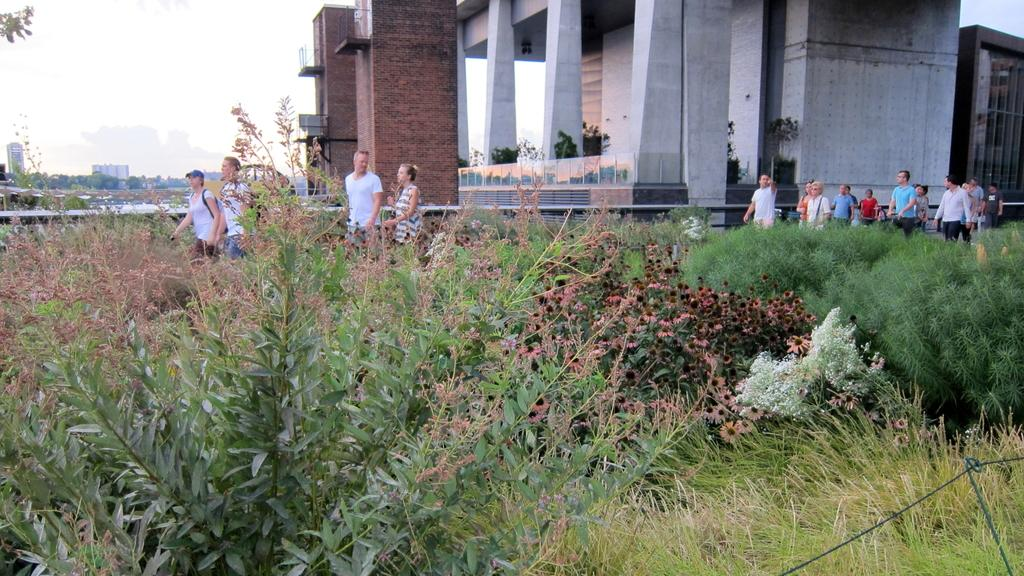What are the people in the image doing? The people in the image are walking. What can be seen under the people's feet in the image? The ground is visible in the image. What type of structure can be seen in the background of the image? There is a concrete house and a brick wall in the background of the image. What type of vegetation is present in the front bottom side of the image? Grass and plants are visible in the front bottom side of the image. Where is the baseball game being played in the image? There is no baseball game present in the image. What type of amusement park can be seen in the image? There is no amusement park present in the image. 